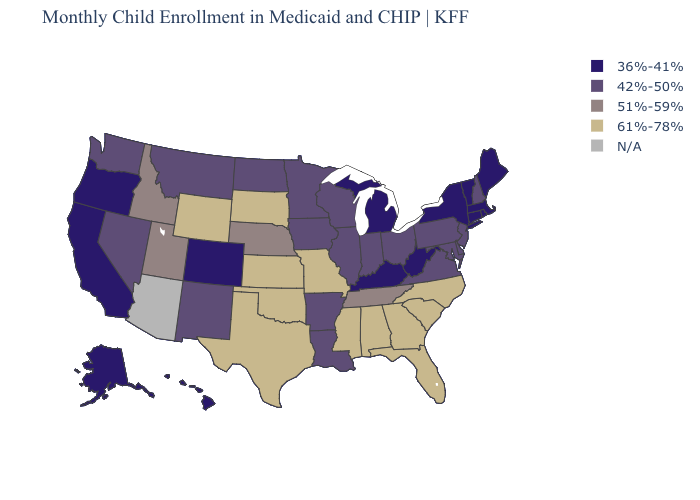Name the states that have a value in the range 61%-78%?
Be succinct. Alabama, Florida, Georgia, Kansas, Mississippi, Missouri, North Carolina, Oklahoma, South Carolina, South Dakota, Texas, Wyoming. Name the states that have a value in the range 51%-59%?
Give a very brief answer. Idaho, Nebraska, Tennessee, Utah. What is the value of Missouri?
Keep it brief. 61%-78%. What is the value of Iowa?
Short answer required. 42%-50%. What is the lowest value in the USA?
Quick response, please. 36%-41%. Does the map have missing data?
Concise answer only. Yes. What is the highest value in states that border Mississippi?
Concise answer only. 61%-78%. How many symbols are there in the legend?
Be succinct. 5. Name the states that have a value in the range 36%-41%?
Answer briefly. Alaska, California, Colorado, Connecticut, Hawaii, Kentucky, Maine, Massachusetts, Michigan, New York, Oregon, Rhode Island, Vermont, West Virginia. What is the lowest value in states that border New Jersey?
Answer briefly. 36%-41%. What is the value of Rhode Island?
Be succinct. 36%-41%. Which states have the lowest value in the USA?
Give a very brief answer. Alaska, California, Colorado, Connecticut, Hawaii, Kentucky, Maine, Massachusetts, Michigan, New York, Oregon, Rhode Island, Vermont, West Virginia. Which states have the lowest value in the Northeast?
Write a very short answer. Connecticut, Maine, Massachusetts, New York, Rhode Island, Vermont. Name the states that have a value in the range 36%-41%?
Answer briefly. Alaska, California, Colorado, Connecticut, Hawaii, Kentucky, Maine, Massachusetts, Michigan, New York, Oregon, Rhode Island, Vermont, West Virginia. Does Connecticut have the lowest value in the Northeast?
Concise answer only. Yes. 